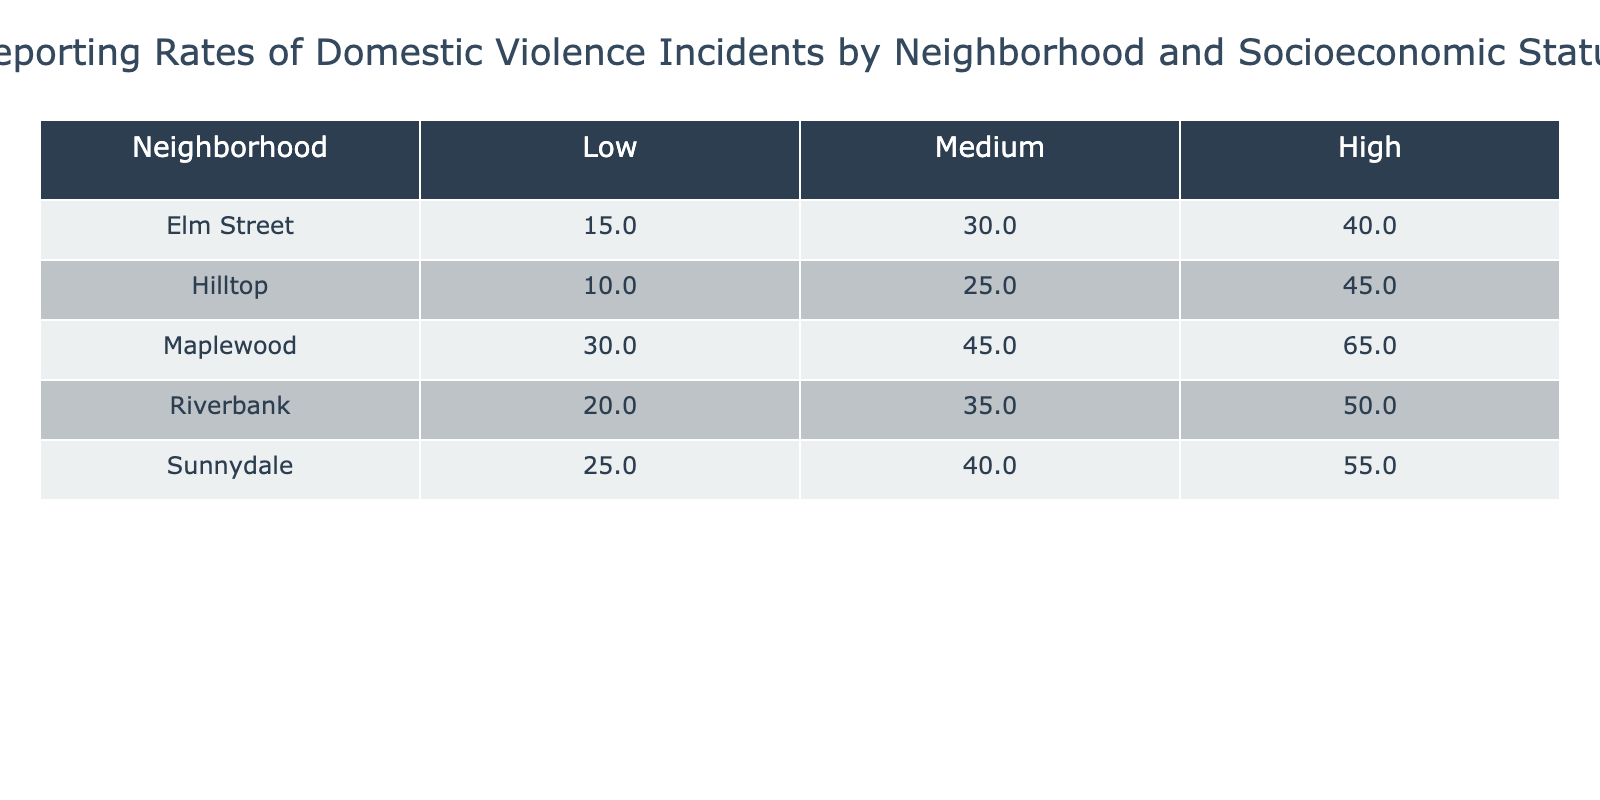What is the reporting rate for domestic violence incidents in the Maplewood neighborhood at a low socioeconomic status? The table lists the reporting rates by neighborhood and socioeconomic status. For Maplewood with a low socioeconomic status, the reporting rate is specifically stated under the 'Low' column for that neighborhood. Looking at the data, the value is 30%.
Answer: 30% Which neighborhood has the highest reporting rate for domestic violence incidents at a medium socioeconomic status? By inspecting the 'Medium' column for each neighborhood, we can compare the values. Sunnydale has a reporting rate of 40%, Maplewood has 45%, Riverbank has 35%, Elm Street has 30%, and Hilltop has 25%. The highest value among these is found in Maplewood with 45%.
Answer: Maplewood What is the average reporting rate for high socioeconomic status across all neighborhoods? To find the average, we need the reporting rates for the high status in each neighborhood: Sunnydale 55%, Maplewood 65%, Riverbank 50%, Elm Street 40%, and Hilltop 45%. The sum of these values is 55 + 65 + 50 + 40 + 45 = 255. There are 5 neighborhoods, so the average is 255/5 = 51%.
Answer: 51% Is the reporting rate for domestic violence incidents in the Hilltop neighborhood at a low socioeconomic status greater than that of Riverbank at a medium socioeconomic status? Looking at the table, the reporting rate for Hilltop at low is 10%, and for Riverbank at medium is 35%. Since 10% is less than 35%, the statement is false.
Answer: No What is the difference in reporting rates between low and high socioeconomic statuses in Sunnydale? For Sunnydale, the reporting rates are 25% for low status and 55% for high status. To find the difference, subtract the low rate from the high rate: 55% - 25% = 30%.
Answer: 30% In which neighborhood does the gap between reporting rates for low and high socioeconomic statuses have the largest value? To find the largest gap, calculate the difference for each neighborhood: Sunnydale (30%), Maplewood (35%), Riverbank (30%), Elm Street (25%), and Hilltop (35%). The largest differences are in Maplewood and Hilltop, which both show a gap of 35%. So the neighborhoods with the largest gap are Maplewood and Hilltop.
Answer: Maplewood and Hilltop Are there any neighborhoods where the reporting rate at high socioeconomic status is lower than at medium socioeconomic status? Checking each neighborhood: Sunnydale shows 55% (high) and 40% (medium), Maplewood shows 65% (high) and 45% (medium), Riverbank shows 50% (high) and 35% (medium), Elm Street shows 40% (high) and 30% (medium), and Hilltop shows 45% (high) and 25% (medium). All neighborhoods have higher rates at high socioeconomic status compared to medium.
Answer: No How many neighborhoods have a reporting rate of 40% or higher for a medium socioeconomic status? We look at the medium status column and identify the neighborhoods with rates: Sunnydale (40%), Maplewood (45%), Riverbank (35%), Elm Street (30%), and Hilltop (25%). Counting those with 40% or above, we find 2 neighborhoods: Sunnydale and Maplewood.
Answer: 2 